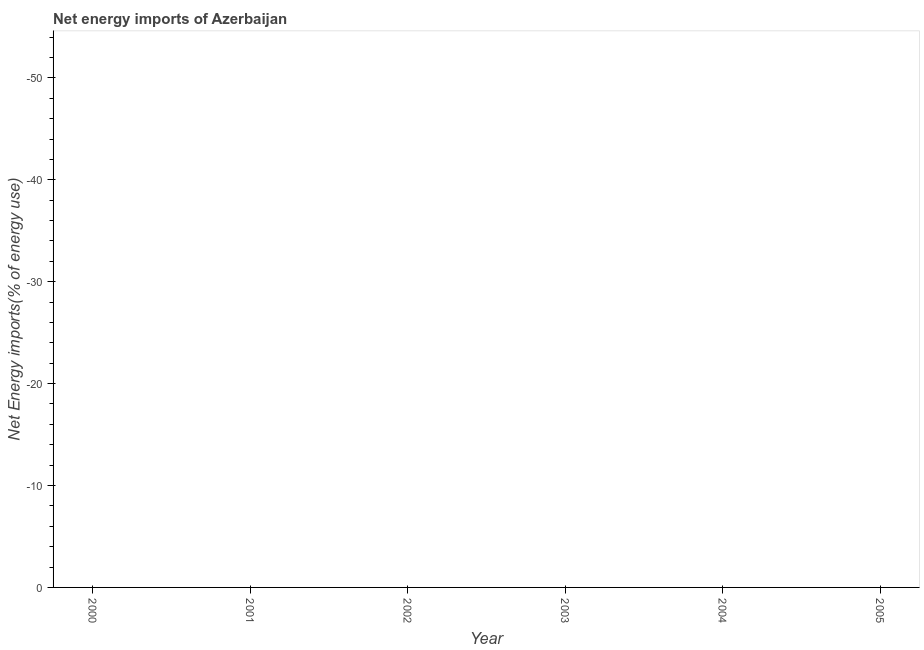Across all years, what is the minimum energy imports?
Offer a terse response. 0. What is the average energy imports per year?
Your answer should be very brief. 0. In how many years, is the energy imports greater than -18 %?
Keep it short and to the point. 0. How many years are there in the graph?
Offer a very short reply. 6. Are the values on the major ticks of Y-axis written in scientific E-notation?
Ensure brevity in your answer.  No. Does the graph contain any zero values?
Keep it short and to the point. Yes. What is the title of the graph?
Your answer should be very brief. Net energy imports of Azerbaijan. What is the label or title of the Y-axis?
Provide a short and direct response. Net Energy imports(% of energy use). What is the Net Energy imports(% of energy use) in 2001?
Offer a very short reply. 0. What is the Net Energy imports(% of energy use) in 2002?
Offer a very short reply. 0. What is the Net Energy imports(% of energy use) of 2004?
Your answer should be very brief. 0. 